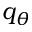Convert formula to latex. <formula><loc_0><loc_0><loc_500><loc_500>q _ { \theta }</formula> 